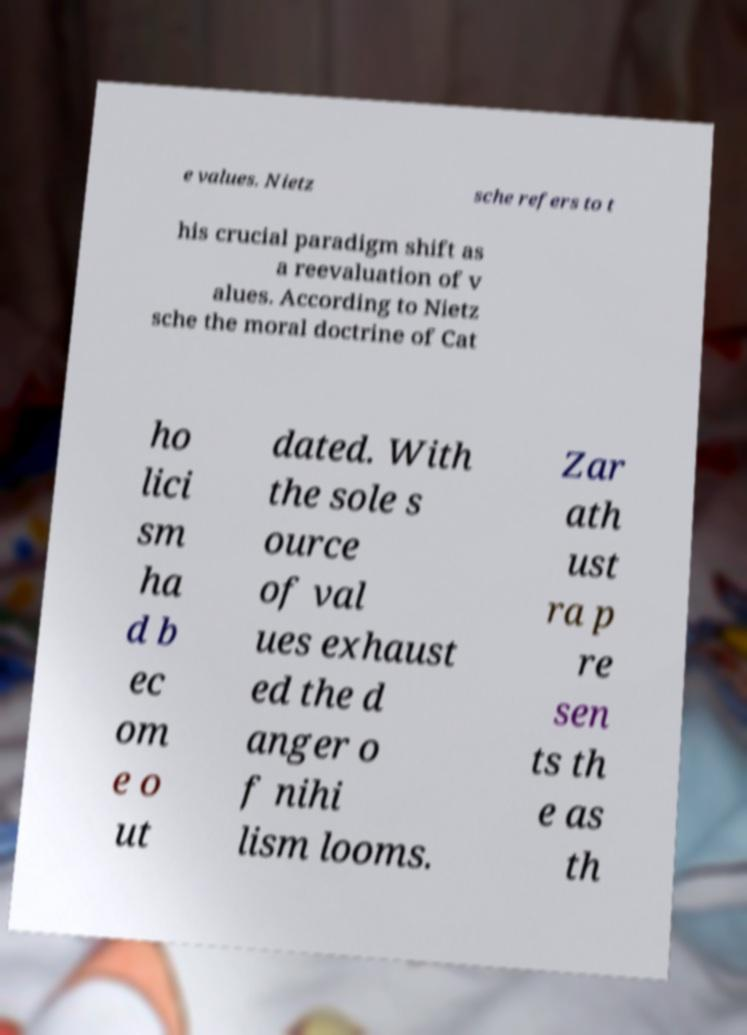What messages or text are displayed in this image? I need them in a readable, typed format. e values. Nietz sche refers to t his crucial paradigm shift as a reevaluation of v alues. According to Nietz sche the moral doctrine of Cat ho lici sm ha d b ec om e o ut dated. With the sole s ource of val ues exhaust ed the d anger o f nihi lism looms. Zar ath ust ra p re sen ts th e as th 